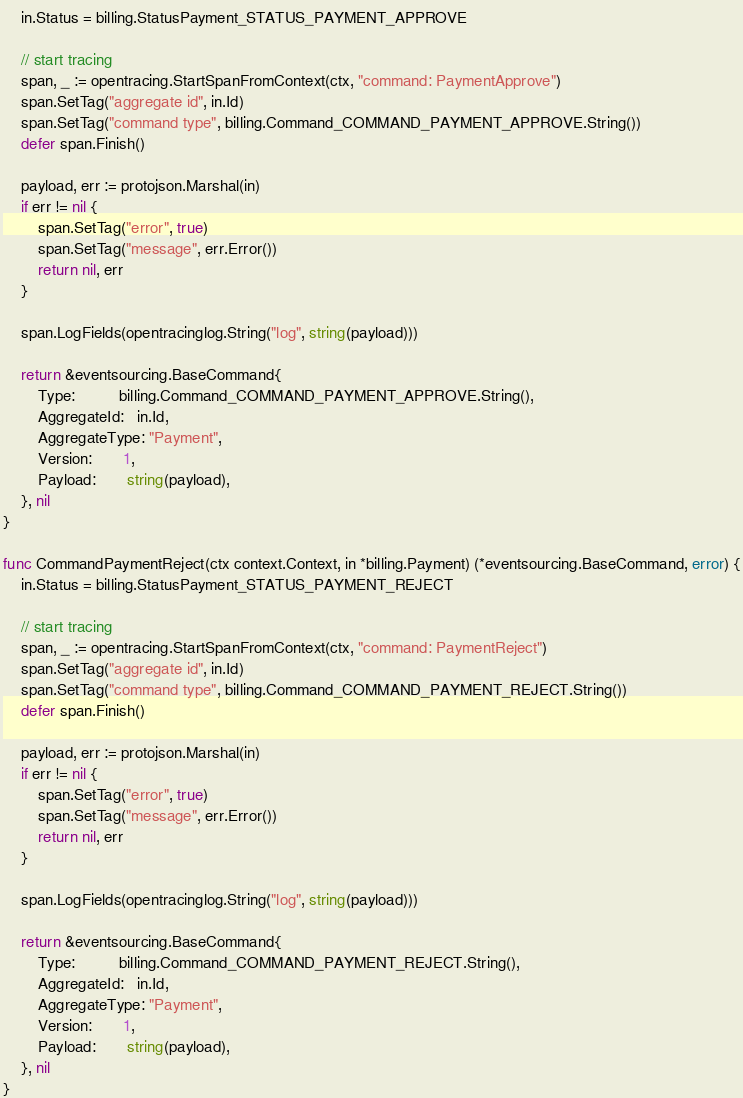<code> <loc_0><loc_0><loc_500><loc_500><_Go_>	in.Status = billing.StatusPayment_STATUS_PAYMENT_APPROVE

	// start tracing
	span, _ := opentracing.StartSpanFromContext(ctx, "command: PaymentApprove")
	span.SetTag("aggregate id", in.Id)
	span.SetTag("command type", billing.Command_COMMAND_PAYMENT_APPROVE.String())
	defer span.Finish()

	payload, err := protojson.Marshal(in)
	if err != nil {
		span.SetTag("error", true)
		span.SetTag("message", err.Error())
		return nil, err
	}

	span.LogFields(opentracinglog.String("log", string(payload)))

	return &eventsourcing.BaseCommand{
		Type:          billing.Command_COMMAND_PAYMENT_APPROVE.String(),
		AggregateId:   in.Id,
		AggregateType: "Payment",
		Version:       1,
		Payload:       string(payload),
	}, nil
}

func CommandPaymentReject(ctx context.Context, in *billing.Payment) (*eventsourcing.BaseCommand, error) {
	in.Status = billing.StatusPayment_STATUS_PAYMENT_REJECT

	// start tracing
	span, _ := opentracing.StartSpanFromContext(ctx, "command: PaymentReject")
	span.SetTag("aggregate id", in.Id)
	span.SetTag("command type", billing.Command_COMMAND_PAYMENT_REJECT.String())
	defer span.Finish()

	payload, err := protojson.Marshal(in)
	if err != nil {
		span.SetTag("error", true)
		span.SetTag("message", err.Error())
		return nil, err
	}

	span.LogFields(opentracinglog.String("log", string(payload)))

	return &eventsourcing.BaseCommand{
		Type:          billing.Command_COMMAND_PAYMENT_REJECT.String(),
		AggregateId:   in.Id,
		AggregateType: "Payment",
		Version:       1,
		Payload:       string(payload),
	}, nil
}
</code> 